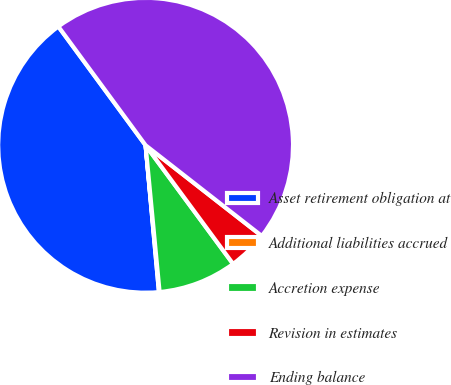Convert chart. <chart><loc_0><loc_0><loc_500><loc_500><pie_chart><fcel>Asset retirement obligation at<fcel>Additional liabilities accrued<fcel>Accretion expense<fcel>Revision in estimates<fcel>Ending balance<nl><fcel>41.36%<fcel>0.07%<fcel>8.6%<fcel>4.34%<fcel>45.63%<nl></chart> 